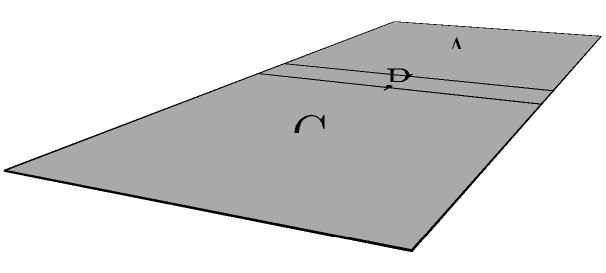As a J-pop album reviewer, you're familiar with CD jewel cases. The diagram shows an unfolded CD case. Which sequence of folds would correctly assemble the case, ensuring the spine (B) is between the base (A) and cover (C)? To correctly assemble the CD jewel case, we need to follow these steps:

1. Identify the parts: 
   A - Base (where the CD sits)
   B - Spine (the narrow part that shows the album title when shelved)
   C - Cover (the front part that opens)

2. Observe the current layout:
   The unfolded case is laid out flat with A-B-C from left to right.

3. Analyze the required final position:
   We need B (spine) between A (base) and C (cover).

4. Determine the folding sequence:
   - First, we need to fold B over A. This is indicated by the left arrow pointing right.
   - Then, we need to fold C over B. This is shown by the right arrow pointing left.

5. Verify the result:
   After these two folds, B (spine) will be between A (base) and C (cover), which is the correct configuration for a CD jewel case.

Therefore, the correct folding sequence is: fold B over A, then fold C over B.
Answer: Fold B over A, then C over B 